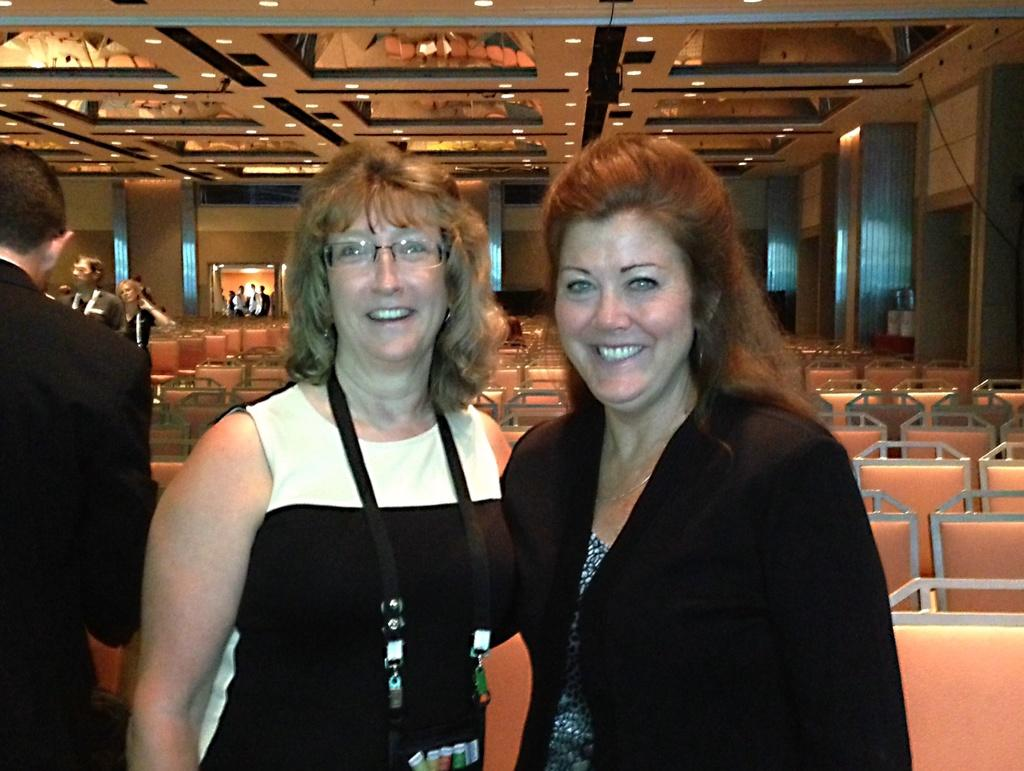What are the people in the image doing? The people in the image are standing on the floor. What type of furniture is present in the image? There are chairs in the image. Are there any people sitting on the chairs? The provided facts do not mention people sitting on the chairs. What can be seen in the background of the image? There is a wall visible in the image, and a roof is also present. What type of lighting is present in the image? There are ceiling lights in the image. How many spiders are crawling on the ceiling lights in the image? There is no mention of spiders in the image, so we cannot determine their presence or number. 